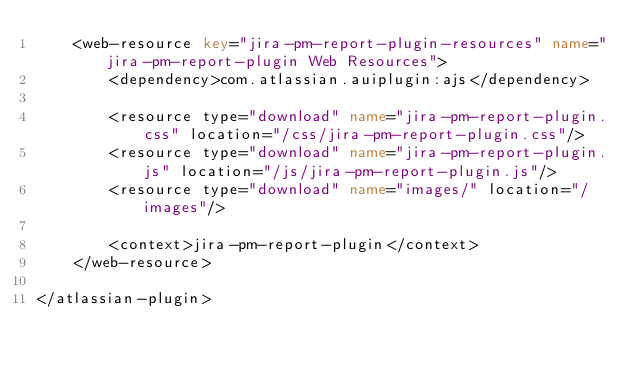<code> <loc_0><loc_0><loc_500><loc_500><_XML_>    <web-resource key="jira-pm-report-plugin-resources" name="jira-pm-report-plugin Web Resources">
        <dependency>com.atlassian.auiplugin:ajs</dependency>
        
        <resource type="download" name="jira-pm-report-plugin.css" location="/css/jira-pm-report-plugin.css"/>
        <resource type="download" name="jira-pm-report-plugin.js" location="/js/jira-pm-report-plugin.js"/>
        <resource type="download" name="images/" location="/images"/>

        <context>jira-pm-report-plugin</context>
    </web-resource>
    
</atlassian-plugin></code> 